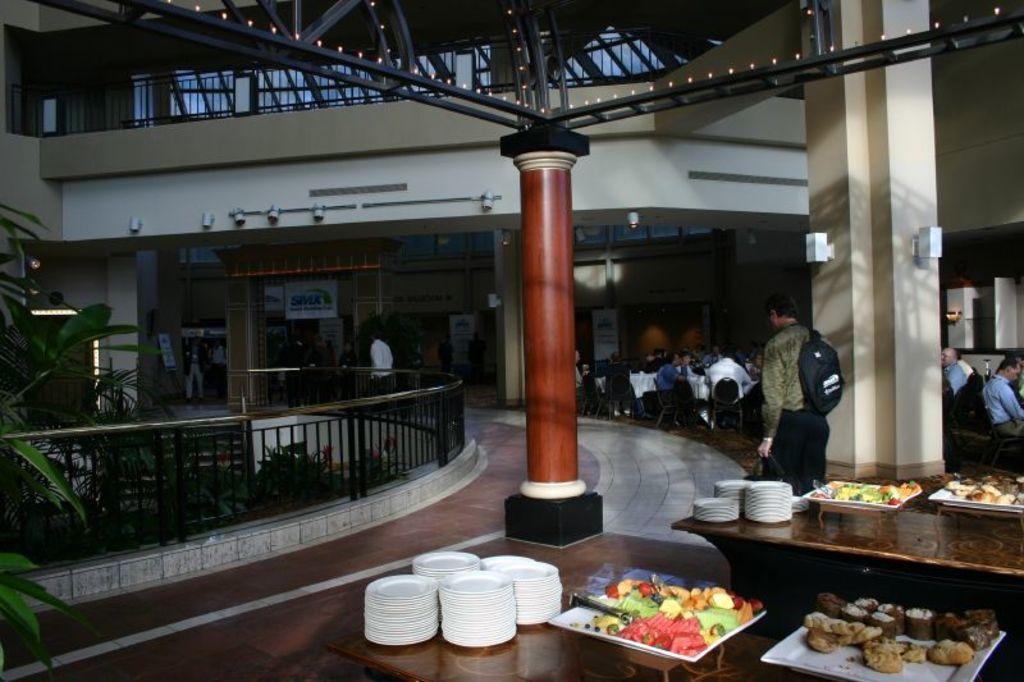In one or two sentences, can you explain what this image depicts? At the bottom of the image there are tables with plates and trays with food items in it. Behind them there are many people sitting on the chairs. Behind them there are walls with posters. At the top of the image there are rods with lights and also there is a pillar. There are few people walking. On the left side of the image there is railing. Behind the railing there are trees. And also there are walls with lights and railings. In the background there are few pillars. 